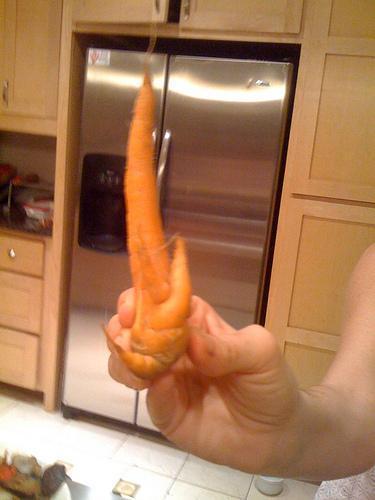How many fingers are shown?
Give a very brief answer. 4. 